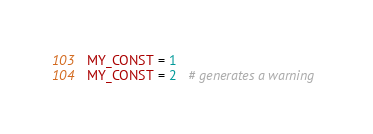<code> <loc_0><loc_0><loc_500><loc_500><_Ruby_>MY_CONST = 1
MY_CONST = 2   # generates a warning
</code> 